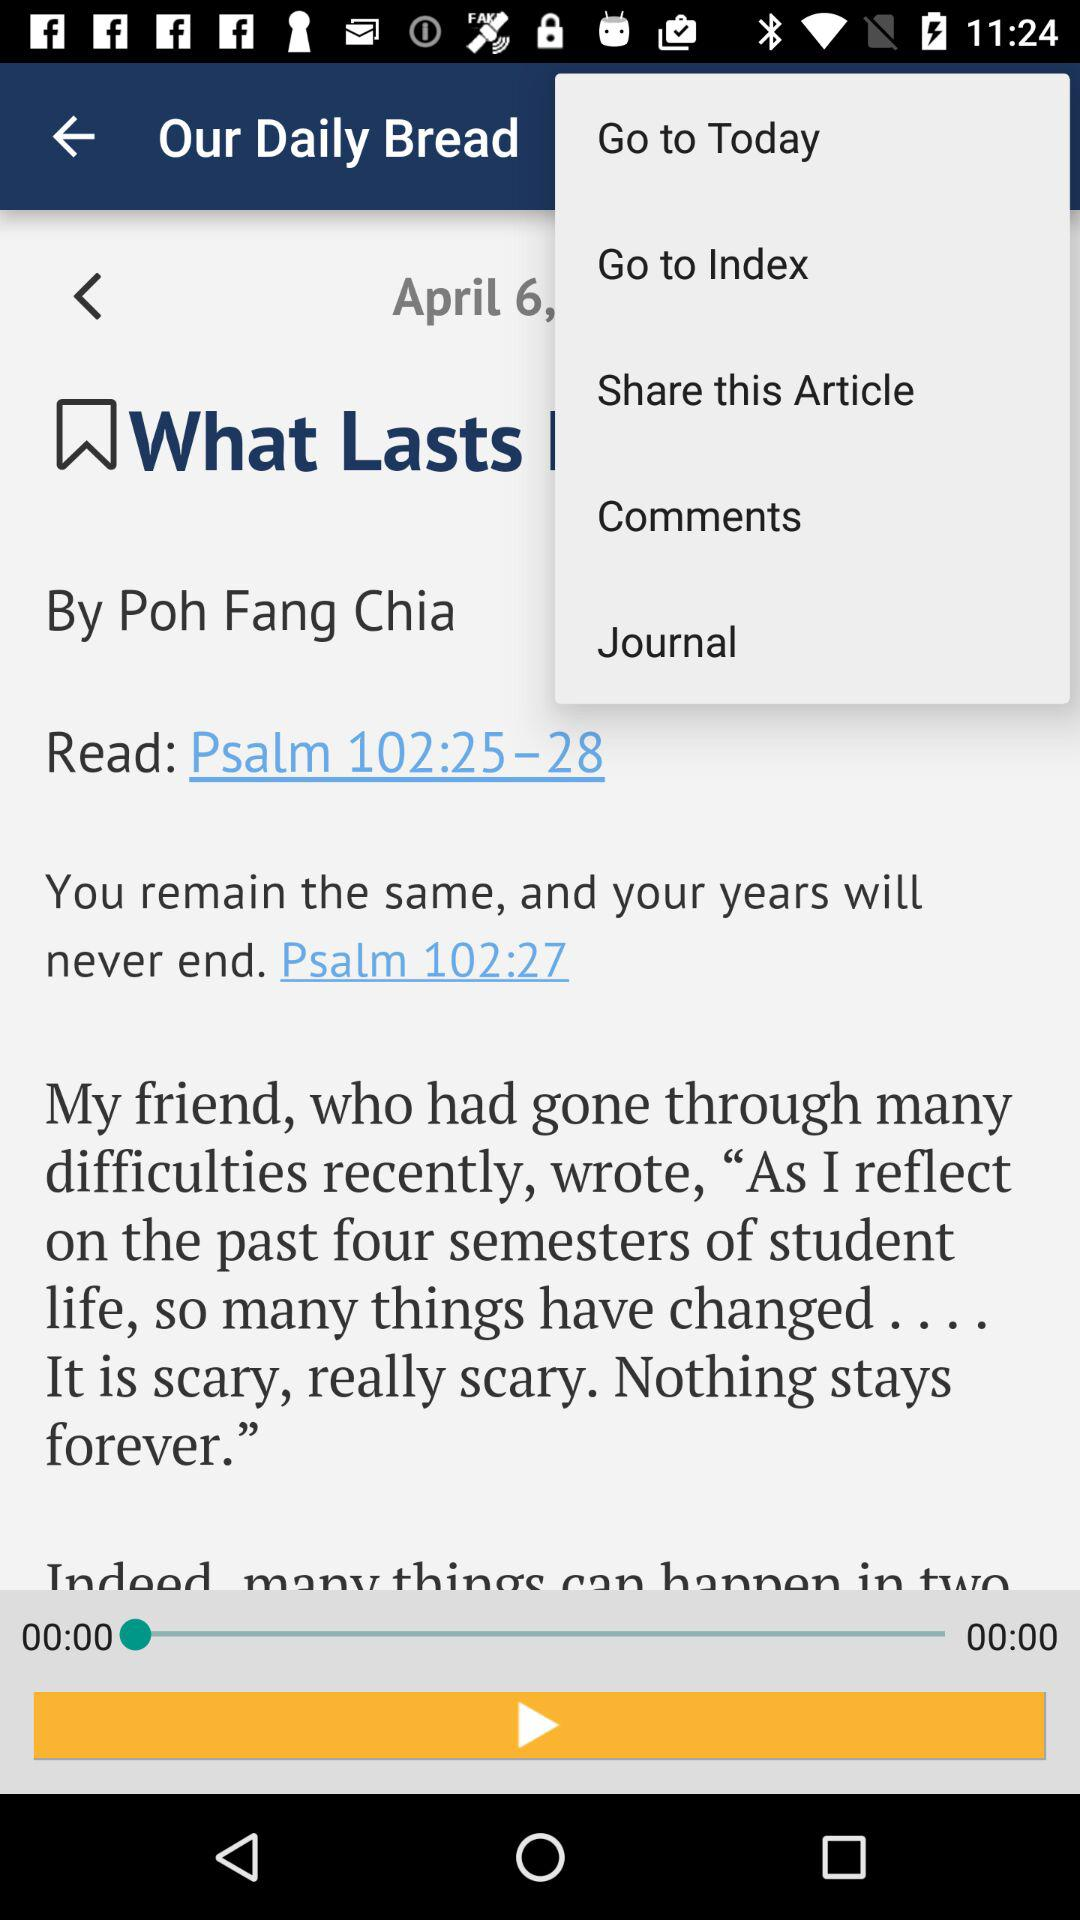Who is the author? The author is "Poh Fang Chia". 